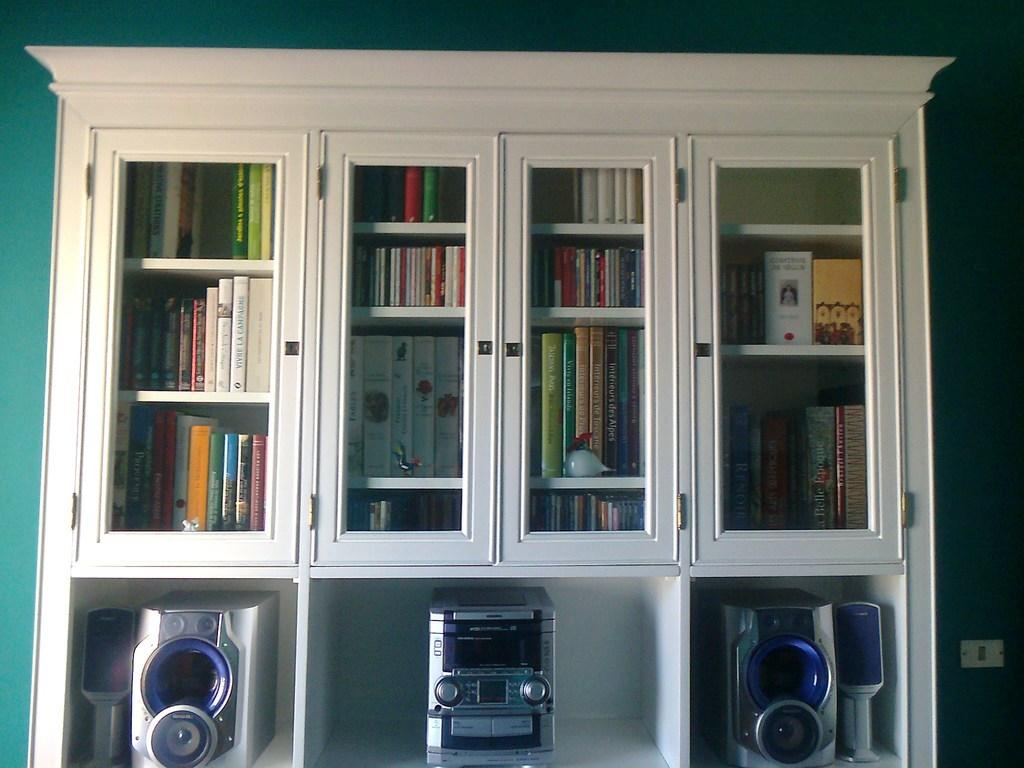<image>
Describe the image concisely. Some fiction books such as Belle Epoque are in the shelf 